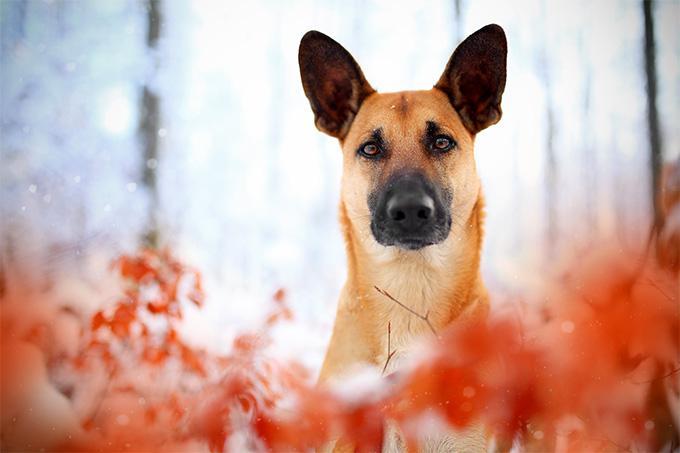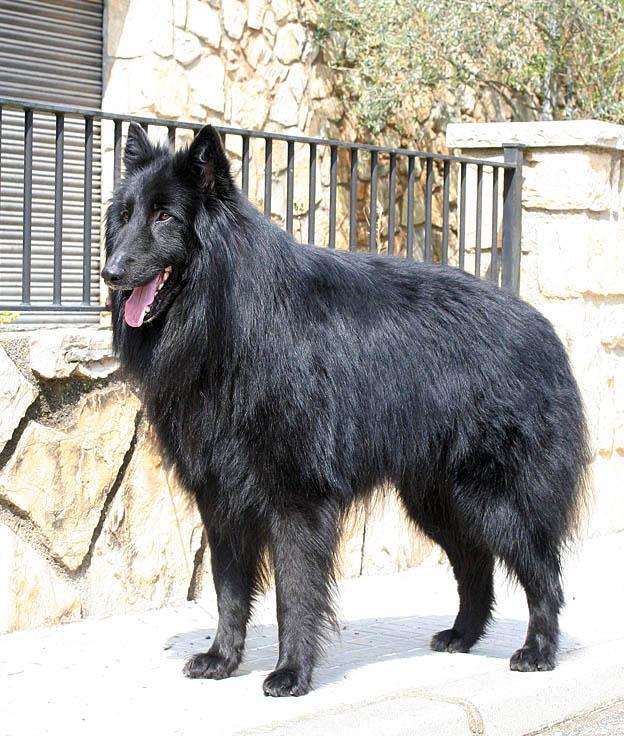The first image is the image on the left, the second image is the image on the right. Evaluate the accuracy of this statement regarding the images: "There is one extended dog tongue in the image on the left.". Is it true? Answer yes or no. No. 